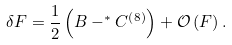Convert formula to latex. <formula><loc_0><loc_0><loc_500><loc_500>\delta F = \frac { 1 } { 2 } \left ( B - ^ { * } C ^ { \left ( 8 \right ) } \right ) + \mathcal { O } \left ( F \right ) .</formula> 